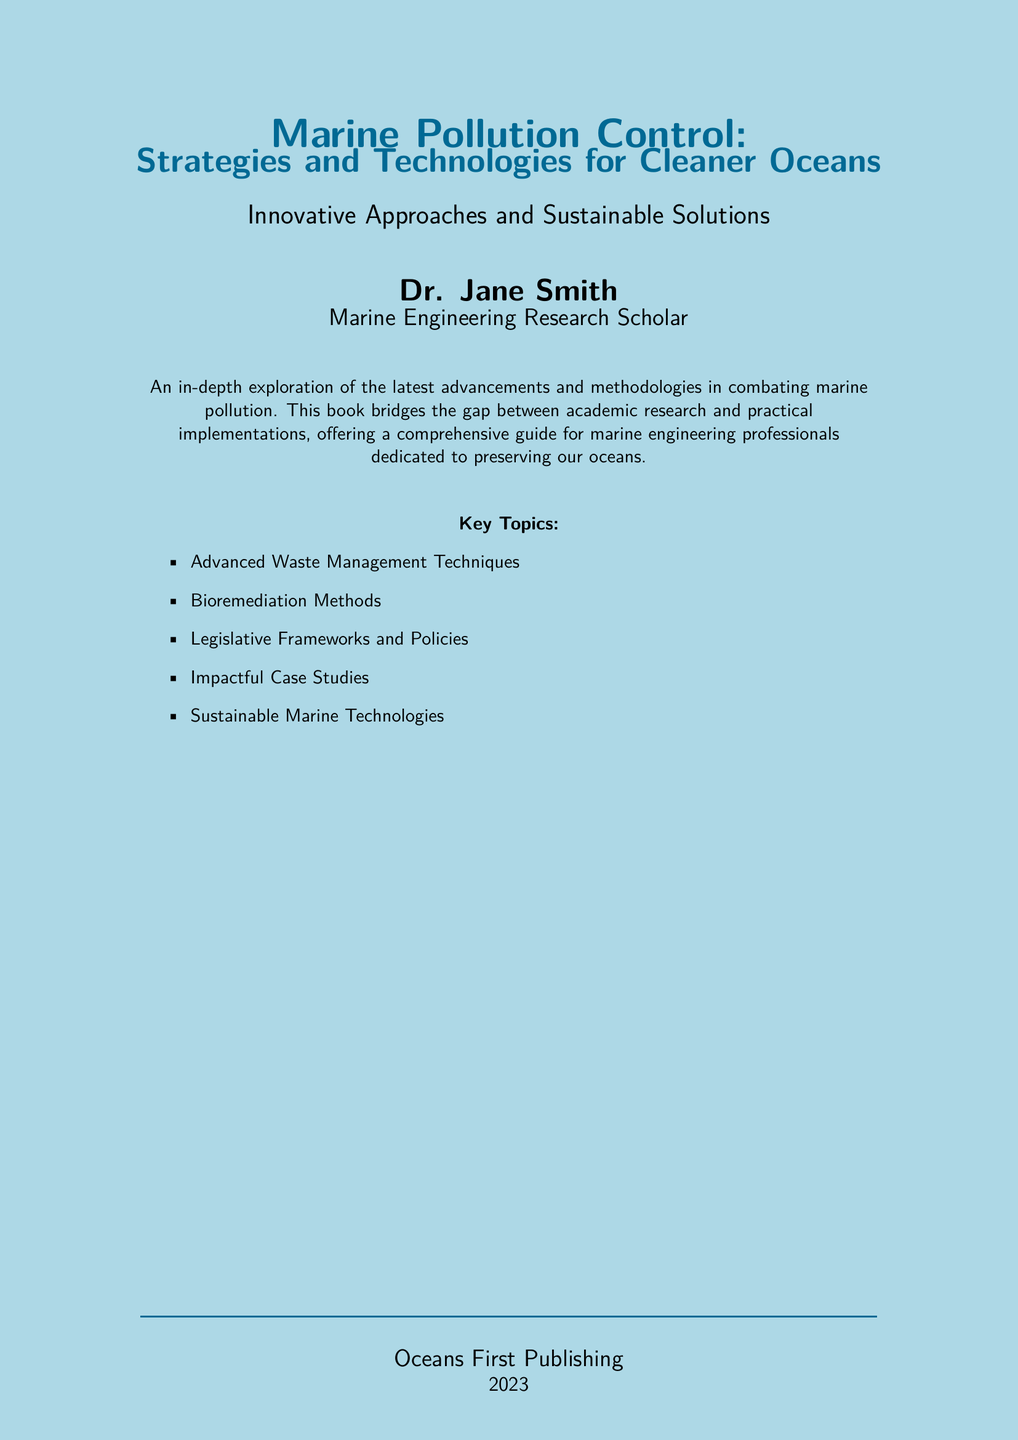What is the title of the book? The title is prominently displayed at the top of the document, which is "Marine Pollution Control: Strategies and Technologies for Cleaner Oceans."
Answer: Marine Pollution Control: Strategies and Technologies for Cleaner Oceans Who is the author of the book? The author's name is listed below the title and is stated as "Dr. Jane Smith."
Answer: Dr. Jane Smith What year was the book published? The publication year is mentioned near the bottom of the document, indicating it was published in 2023.
Answer: 2023 What is the main focus of the book? The main focus is described in the document as an "in-depth exploration of the latest advancements and methodologies in combating marine pollution."
Answer: Combating marine pollution What color is used for the title? The color of the title text is specified in the document as "oceanblue."
Answer: oceanblue How many key topics are listed in the document? The list of key topics is itemized, and there are five topics mentioned.
Answer: Five What publishing company released the book? The company responsible for publishing the book is stated as "Oceans First Publishing."
Answer: Oceans First Publishing What is a highlighted strategy mentioned in the key topics? One of the key topics includes "Bioremediation Methods."
Answer: Bioremediation Methods Which profession is associated with Dr. Jane Smith? Dr. Jane Smith's profession is mentioned in the document as a "Marine Engineering Research Scholar."
Answer: Marine Engineering Research Scholar 